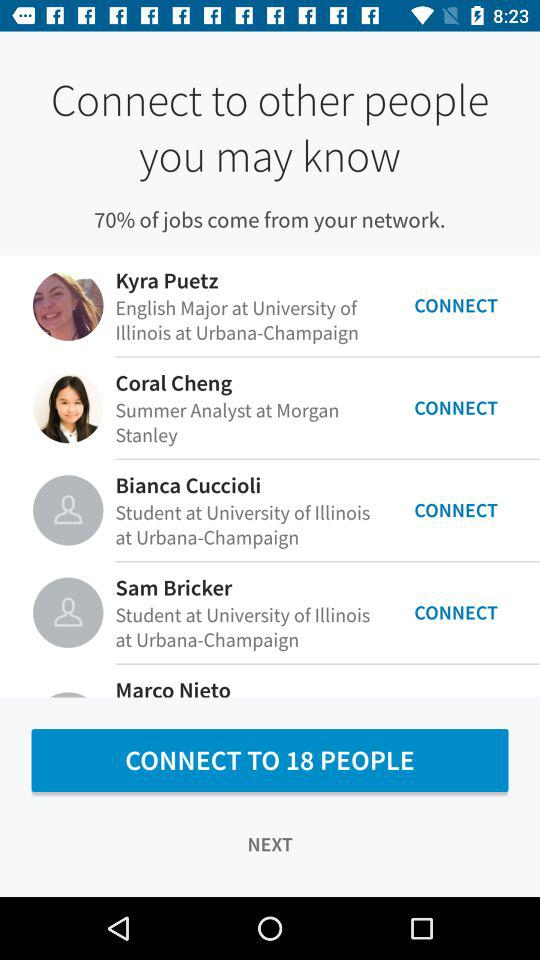From which university is Sam Bricker? Sam Bricker is from the University of Illinois at Urbana-Champaign. 